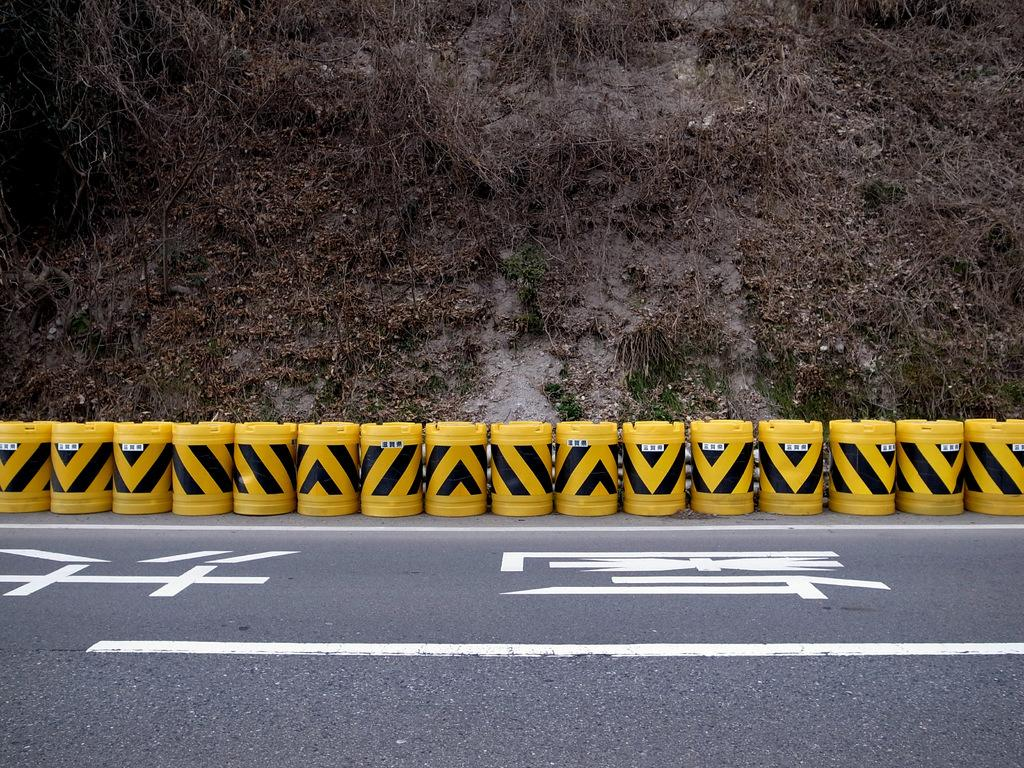What is the main feature of the image? There is a road in the image. Are there any additional objects or features related to the road? Yes, there are objects that resemble traffic barrels behind the road. What can be seen in the distance in the image? There appears to be a hill in the background of the image. Can you see any cracks in the road in the image? There is no mention of cracks in the road in the provided facts, so we cannot determine if any cracks are present. What type of nerve is visible in the image? There is no mention of a nerve in the provided facts, so we cannot determine if any nerve is present. 